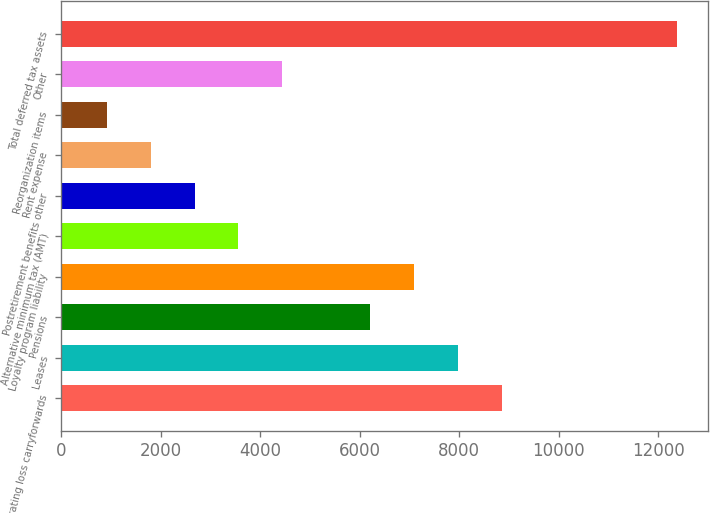Convert chart to OTSL. <chart><loc_0><loc_0><loc_500><loc_500><bar_chart><fcel>Operating loss carryforwards<fcel>Leases<fcel>Pensions<fcel>Loyalty program liability<fcel>Alternative minimum tax (AMT)<fcel>Postretirement benefits other<fcel>Rent expense<fcel>Reorganization items<fcel>Other<fcel>Total deferred tax assets<nl><fcel>8852<fcel>7969.8<fcel>6205.4<fcel>7087.6<fcel>3558.8<fcel>2676.6<fcel>1794.4<fcel>912.2<fcel>4441<fcel>12380.8<nl></chart> 